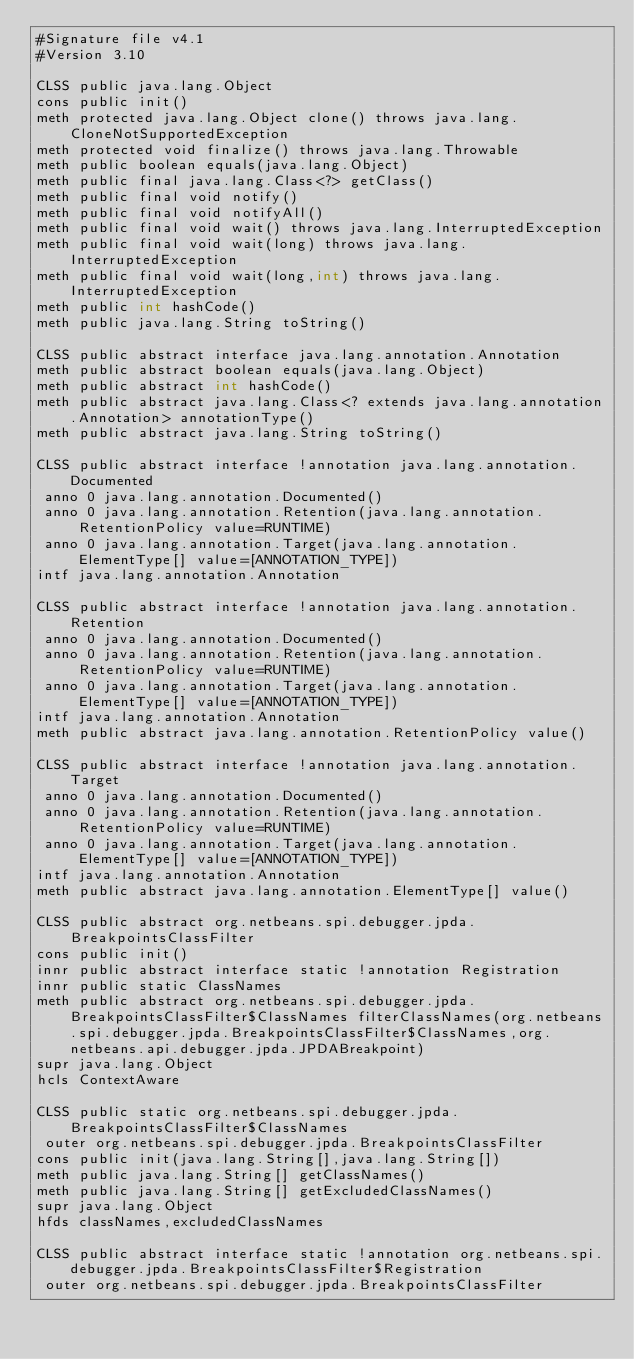<code> <loc_0><loc_0><loc_500><loc_500><_SML_>#Signature file v4.1
#Version 3.10

CLSS public java.lang.Object
cons public init()
meth protected java.lang.Object clone() throws java.lang.CloneNotSupportedException
meth protected void finalize() throws java.lang.Throwable
meth public boolean equals(java.lang.Object)
meth public final java.lang.Class<?> getClass()
meth public final void notify()
meth public final void notifyAll()
meth public final void wait() throws java.lang.InterruptedException
meth public final void wait(long) throws java.lang.InterruptedException
meth public final void wait(long,int) throws java.lang.InterruptedException
meth public int hashCode()
meth public java.lang.String toString()

CLSS public abstract interface java.lang.annotation.Annotation
meth public abstract boolean equals(java.lang.Object)
meth public abstract int hashCode()
meth public abstract java.lang.Class<? extends java.lang.annotation.Annotation> annotationType()
meth public abstract java.lang.String toString()

CLSS public abstract interface !annotation java.lang.annotation.Documented
 anno 0 java.lang.annotation.Documented()
 anno 0 java.lang.annotation.Retention(java.lang.annotation.RetentionPolicy value=RUNTIME)
 anno 0 java.lang.annotation.Target(java.lang.annotation.ElementType[] value=[ANNOTATION_TYPE])
intf java.lang.annotation.Annotation

CLSS public abstract interface !annotation java.lang.annotation.Retention
 anno 0 java.lang.annotation.Documented()
 anno 0 java.lang.annotation.Retention(java.lang.annotation.RetentionPolicy value=RUNTIME)
 anno 0 java.lang.annotation.Target(java.lang.annotation.ElementType[] value=[ANNOTATION_TYPE])
intf java.lang.annotation.Annotation
meth public abstract java.lang.annotation.RetentionPolicy value()

CLSS public abstract interface !annotation java.lang.annotation.Target
 anno 0 java.lang.annotation.Documented()
 anno 0 java.lang.annotation.Retention(java.lang.annotation.RetentionPolicy value=RUNTIME)
 anno 0 java.lang.annotation.Target(java.lang.annotation.ElementType[] value=[ANNOTATION_TYPE])
intf java.lang.annotation.Annotation
meth public abstract java.lang.annotation.ElementType[] value()

CLSS public abstract org.netbeans.spi.debugger.jpda.BreakpointsClassFilter
cons public init()
innr public abstract interface static !annotation Registration
innr public static ClassNames
meth public abstract org.netbeans.spi.debugger.jpda.BreakpointsClassFilter$ClassNames filterClassNames(org.netbeans.spi.debugger.jpda.BreakpointsClassFilter$ClassNames,org.netbeans.api.debugger.jpda.JPDABreakpoint)
supr java.lang.Object
hcls ContextAware

CLSS public static org.netbeans.spi.debugger.jpda.BreakpointsClassFilter$ClassNames
 outer org.netbeans.spi.debugger.jpda.BreakpointsClassFilter
cons public init(java.lang.String[],java.lang.String[])
meth public java.lang.String[] getClassNames()
meth public java.lang.String[] getExcludedClassNames()
supr java.lang.Object
hfds classNames,excludedClassNames

CLSS public abstract interface static !annotation org.netbeans.spi.debugger.jpda.BreakpointsClassFilter$Registration
 outer org.netbeans.spi.debugger.jpda.BreakpointsClassFilter</code> 